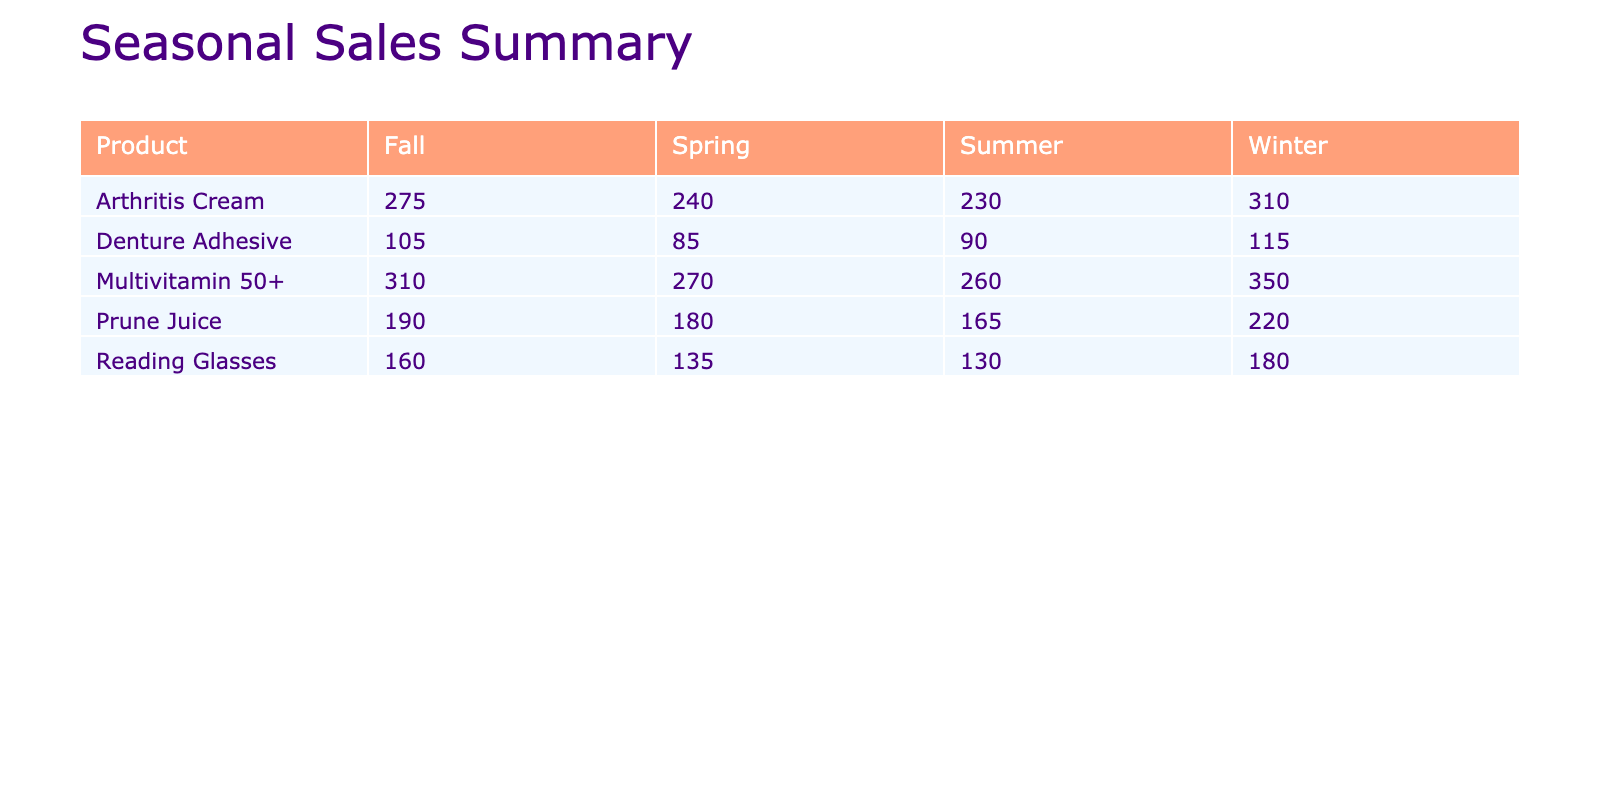What is the highest sales after discount for Prune Juice? The sales after discount for Prune Juice in Winter is 220, which is more than the other seasons (Spring: 180, Summer: 165, Fall: 190). Thus, the highest sales is in Winter.
Answer: 220 Which product had the lowest sales after discount in Spring? In Spring, Denture Adhesive had sales after discount of 85, while all other products had higher sales (Prune Juice: 180, Arthritis Cream: 240, Reading Glasses: 135, Multivitamin 50+: 270). Therefore, Denture Adhesive has the lowest sales.
Answer: 85 What was the average sales after discount for Arthritis Cream across all seasons? The sales after discount for Arthritis Cream are: Spring: 240, Summer: 230, Fall: 275, Winter: 310. Summing them gives 240 + 230 + 275 + 310 = 1055. Dividing by 4 seasons gives an average of 1055 / 4 = 263.75.
Answer: 263.75 Did any season for Multivitamin 50+ have sales after discount less than 300? In examining the sales after discount for Multivitamin 50+, Spring has 270, Summer has 260, Fall has 310, and Winter has 350. Spring and Summer both have less than 300. Therefore, it is true that at least one season had sales below 300.
Answer: Yes Which product experienced the greatest increase in sales after discount from Spring to Winter? Calculating the increase for each product: Prune Juice (Spring: 180 to Winter: 220) = 40, Denture Adhesive (Spring: 85 to Winter: 115) = 30, Arthritis Cream (Spring: 240 to Winter: 310) = 70, Reading Glasses (Spring: 135 to Winter: 180) = 45, Multivitamin 50+ (Spring: 270 to Winter: 350) = 80. Multivitamin 50+ shows the greatest increase of 80.
Answer: 80 